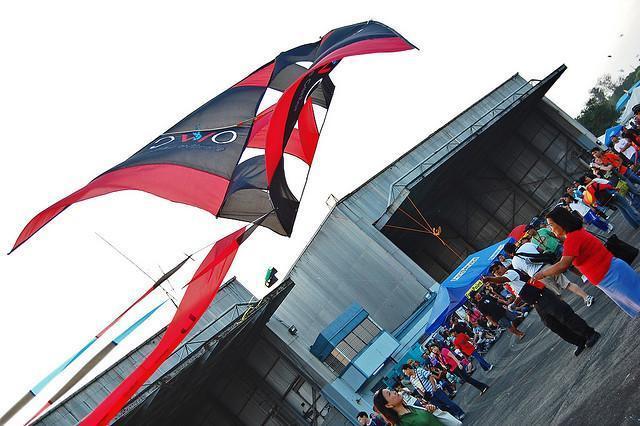How many people are in the picture?
Give a very brief answer. 3. 